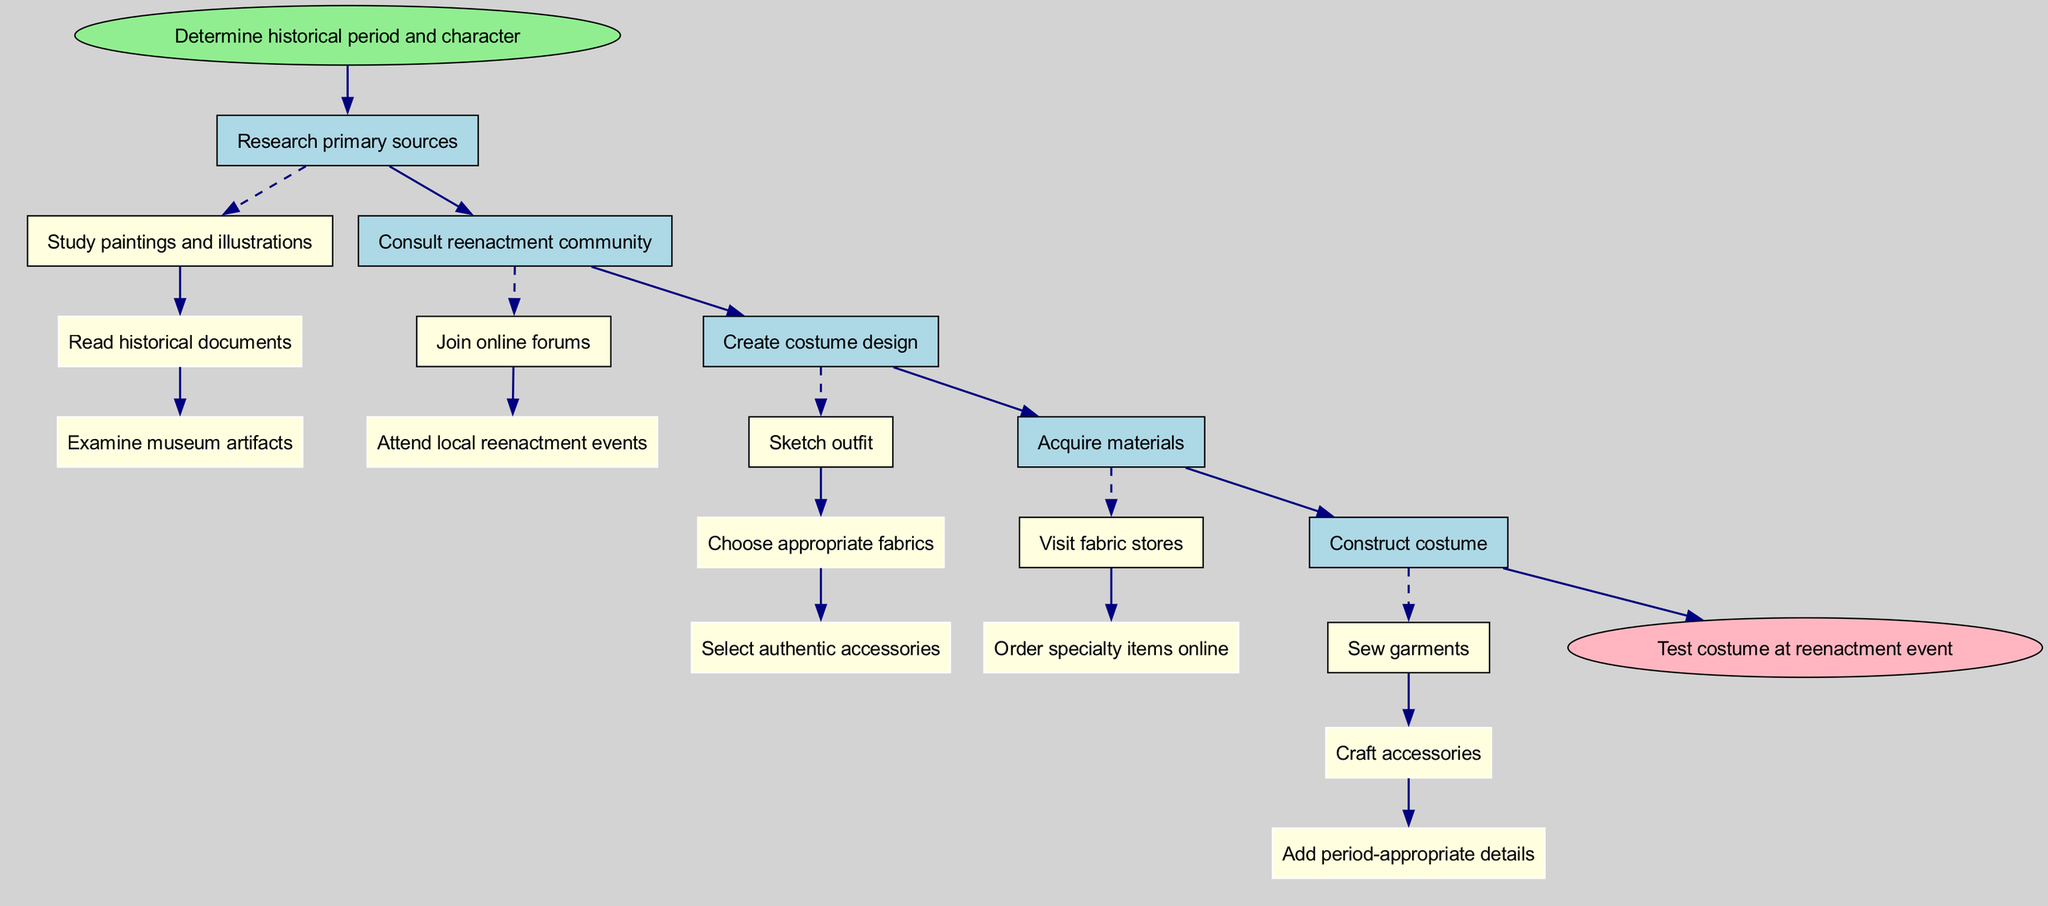What is the first step in the research process? The diagram starts with the node labeled "Determine historical period and character," which indicates that this is the first action one should take.
Answer: Determine historical period and character How many main steps are there in the costume creation process? By counting the nodes connected directly to the start node, one can see that there are five main steps in total.
Answer: 5 Which step involves consulting the reenactment community? In the diagram, the step labeled "Consult reenactment community" clearly indicates where this action takes place.
Answer: Consult reenactment community What is the last action taken in the process? The end node labeled "Test costume at reenactment event" represents the final action that concludes the costume research and creation process.
Answer: Test costume at reenactment event What are two substeps under "Create costume design"? The substeps listed under "Create costume design" include "Sketch outfit," and "Choose appropriate fabrics," indicating two key actions within this step.
Answer: Sketch outfit, Choose appropriate fabrics Which step follows "Acquire materials"? In the flow of the diagram, the step that follows "Acquire materials" is "Construct costume," showing the progression from gathering materials to actually building the costume.
Answer: Construct costume What type of edges connect substeps to their main steps? The edges that connect the substeps to their respective main steps are styled as dashed, indicating a different type of connection in the flowchart.
Answer: Dashed edges What is the connection between "Research primary sources" and "Create costume design"? The flow from "Research primary sources" to "Create costume design" illustrates that after researching, one moves on to designing the costume, indicating the sequence of actions.
Answer: Sequential connection How many substeps are associated with the step "Construct costume"? Upon examining the "Construct costume" step, it is clear that there are three substeps listed: "Sew garments," "Craft accessories," and "Add period-appropriate details."
Answer: 3 